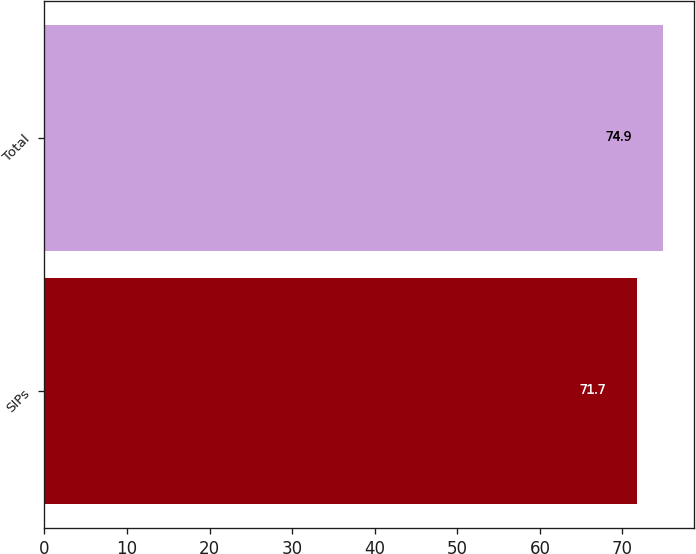<chart> <loc_0><loc_0><loc_500><loc_500><bar_chart><fcel>SIPs<fcel>Total<nl><fcel>71.7<fcel>74.9<nl></chart> 